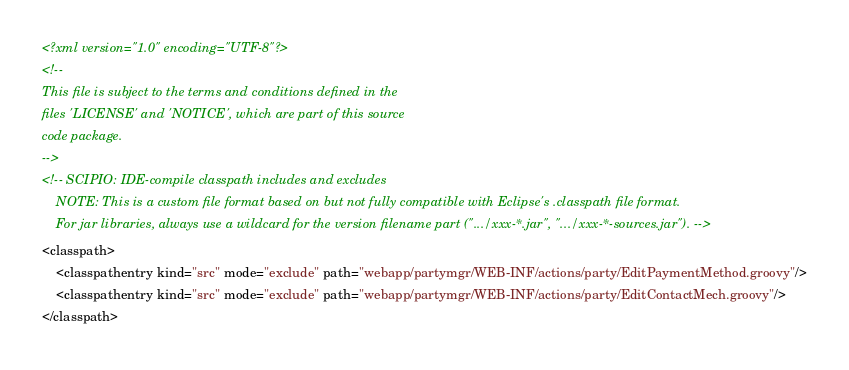Convert code to text. <code><loc_0><loc_0><loc_500><loc_500><_XML_><?xml version="1.0" encoding="UTF-8"?>
<!--
This file is subject to the terms and conditions defined in the
files 'LICENSE' and 'NOTICE', which are part of this source
code package.
-->
<!-- SCIPIO: IDE-compile classpath includes and excludes
    NOTE: This is a custom file format based on but not fully compatible with Eclipse's .classpath file format.
    For jar libraries, always use a wildcard for the version filename part (".../xxx-*.jar", ".../xxx-*-sources.jar"). -->
<classpath>
    <classpathentry kind="src" mode="exclude" path="webapp/partymgr/WEB-INF/actions/party/EditPaymentMethod.groovy"/>
    <classpathentry kind="src" mode="exclude" path="webapp/partymgr/WEB-INF/actions/party/EditContactMech.groovy"/>
</classpath>
</code> 